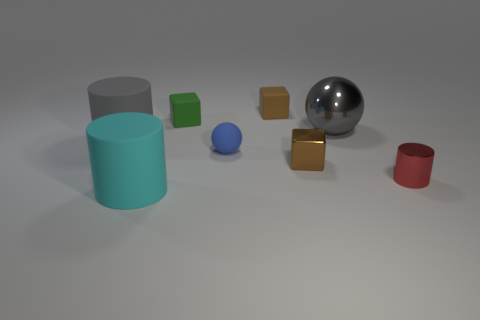How many rubber blocks have the same color as the small cylinder?
Provide a short and direct response. 0. What number of other things are the same color as the small shiny cylinder?
Your response must be concise. 0. Is the number of small red objects greater than the number of yellow metal balls?
Ensure brevity in your answer.  Yes. What is the material of the large gray cylinder?
Offer a terse response. Rubber. There is a gray metal ball that is in front of the green block; does it have the same size as the green object?
Your answer should be compact. No. There is a cylinder in front of the red thing; what is its size?
Provide a short and direct response. Large. Is there any other thing that is made of the same material as the large gray ball?
Give a very brief answer. Yes. What number of big gray metal blocks are there?
Your answer should be very brief. 0. Is the large metallic thing the same color as the tiny cylinder?
Keep it short and to the point. No. The tiny cube that is in front of the tiny brown matte block and right of the small blue object is what color?
Your answer should be very brief. Brown. 